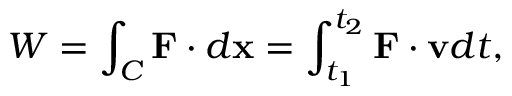<formula> <loc_0><loc_0><loc_500><loc_500>W = \int _ { C } F \cdot d x = \int _ { t _ { 1 } } ^ { t _ { 2 } } F \cdot v d t ,</formula> 